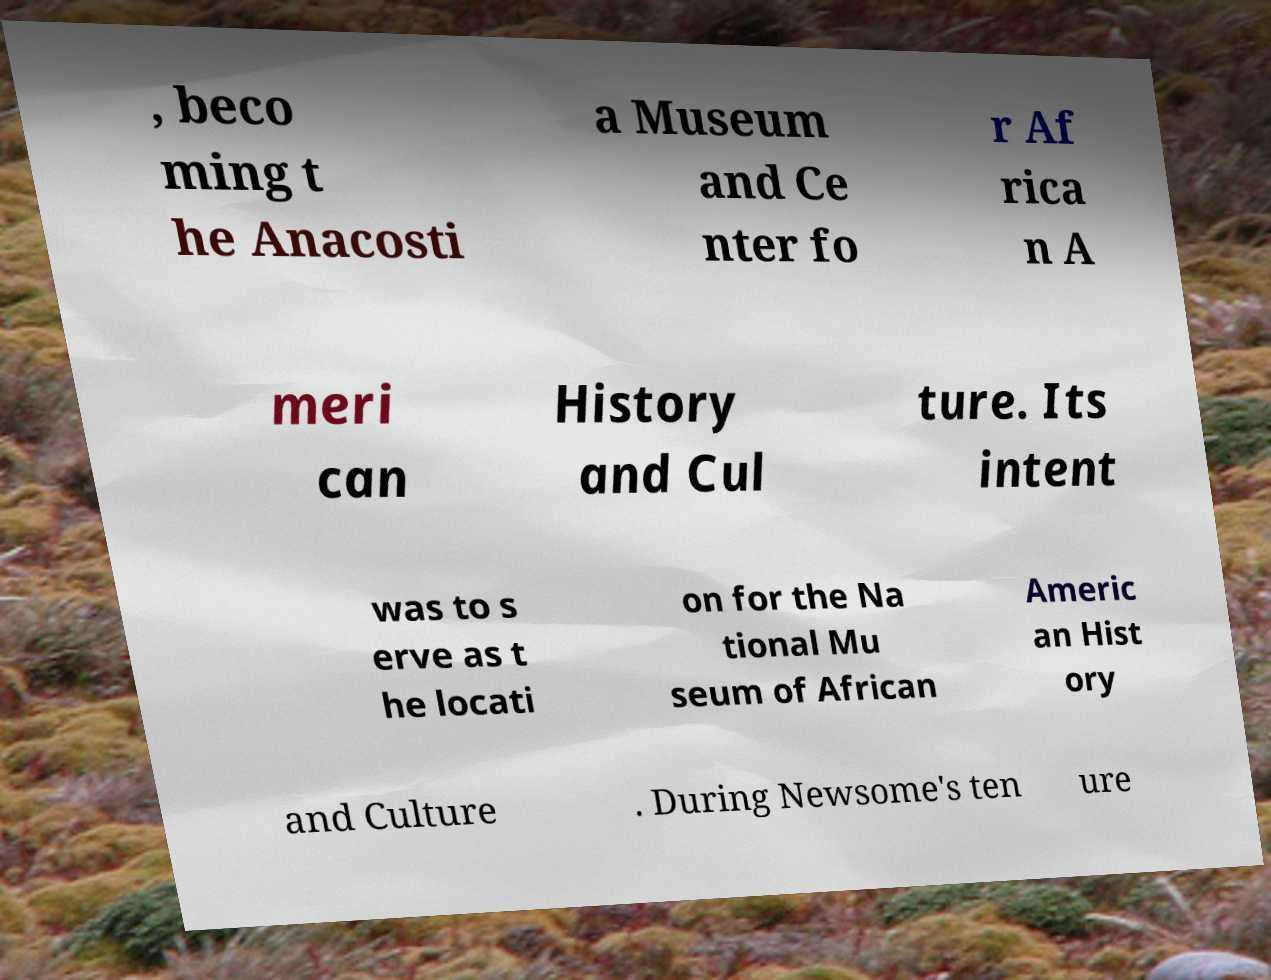Could you assist in decoding the text presented in this image and type it out clearly? , beco ming t he Anacosti a Museum and Ce nter fo r Af rica n A meri can History and Cul ture. Its intent was to s erve as t he locati on for the Na tional Mu seum of African Americ an Hist ory and Culture . During Newsome's ten ure 